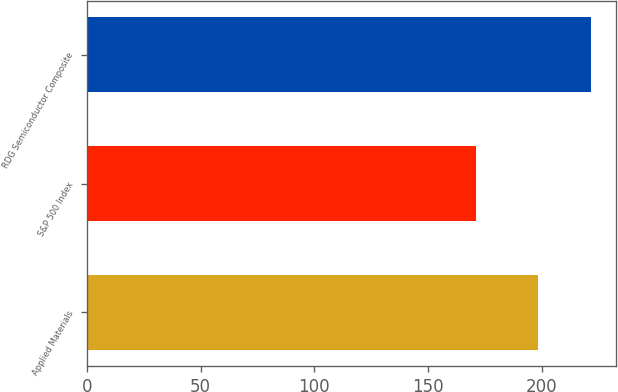Convert chart to OTSL. <chart><loc_0><loc_0><loc_500><loc_500><bar_chart><fcel>Applied Materials<fcel>S&P 500 Index<fcel>RDG Semiconductor Composite<nl><fcel>198.27<fcel>171.11<fcel>221.61<nl></chart> 